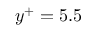Convert formula to latex. <formula><loc_0><loc_0><loc_500><loc_500>y ^ { + } = 5 . 5</formula> 